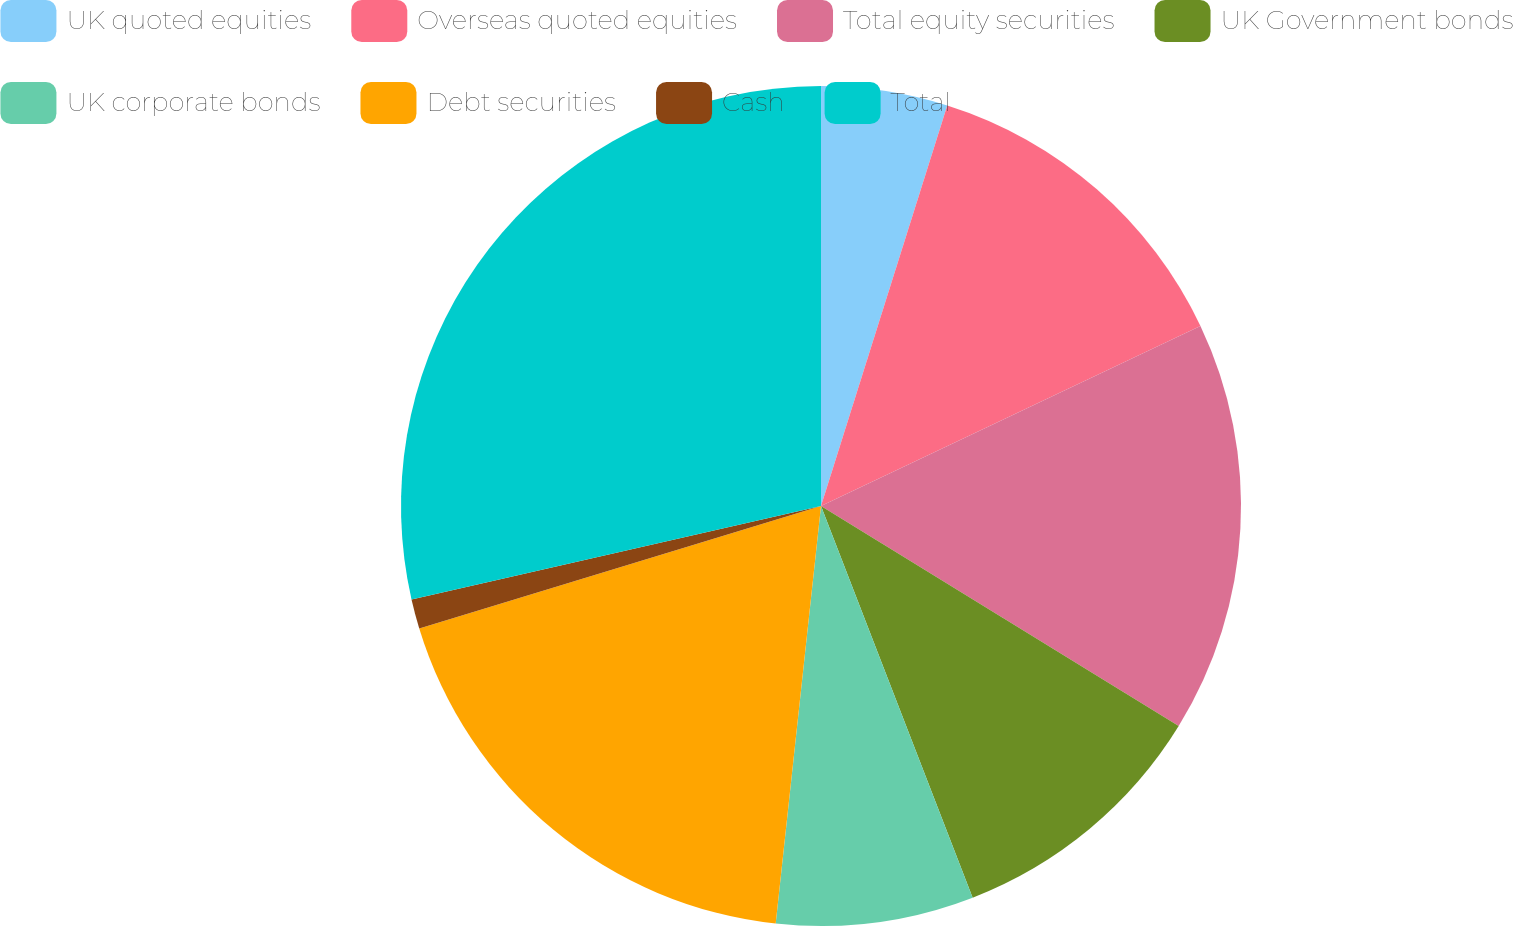Convert chart. <chart><loc_0><loc_0><loc_500><loc_500><pie_chart><fcel>UK quoted equities<fcel>Overseas quoted equities<fcel>Total equity securities<fcel>UK Government bonds<fcel>UK corporate bonds<fcel>Debt securities<fcel>Cash<fcel>Total<nl><fcel>4.86%<fcel>13.09%<fcel>15.83%<fcel>10.34%<fcel>7.6%<fcel>18.57%<fcel>1.14%<fcel>28.57%<nl></chart> 